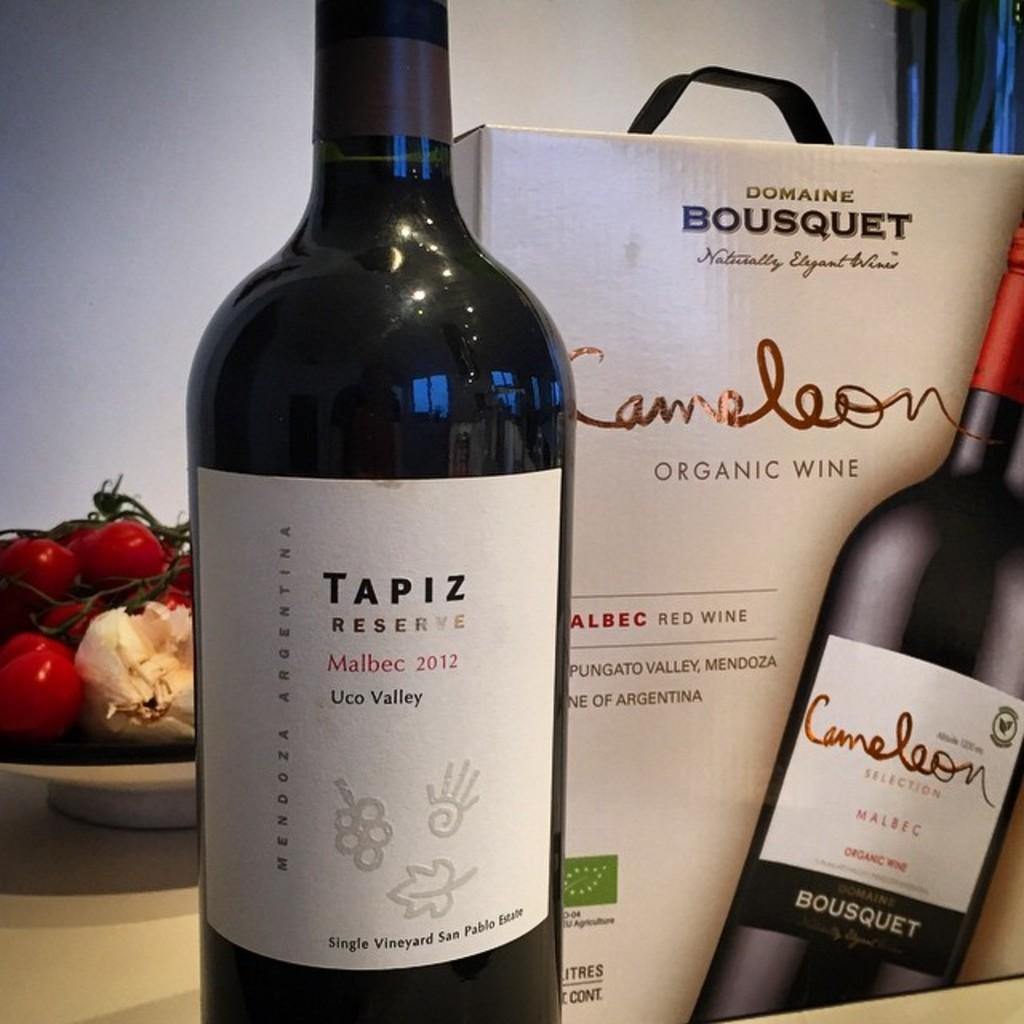<image>
Render a clear and concise summary of the photo. A bottle of Tapiz Reserve on a counter next to a box containing Cameleon Organic wine. 